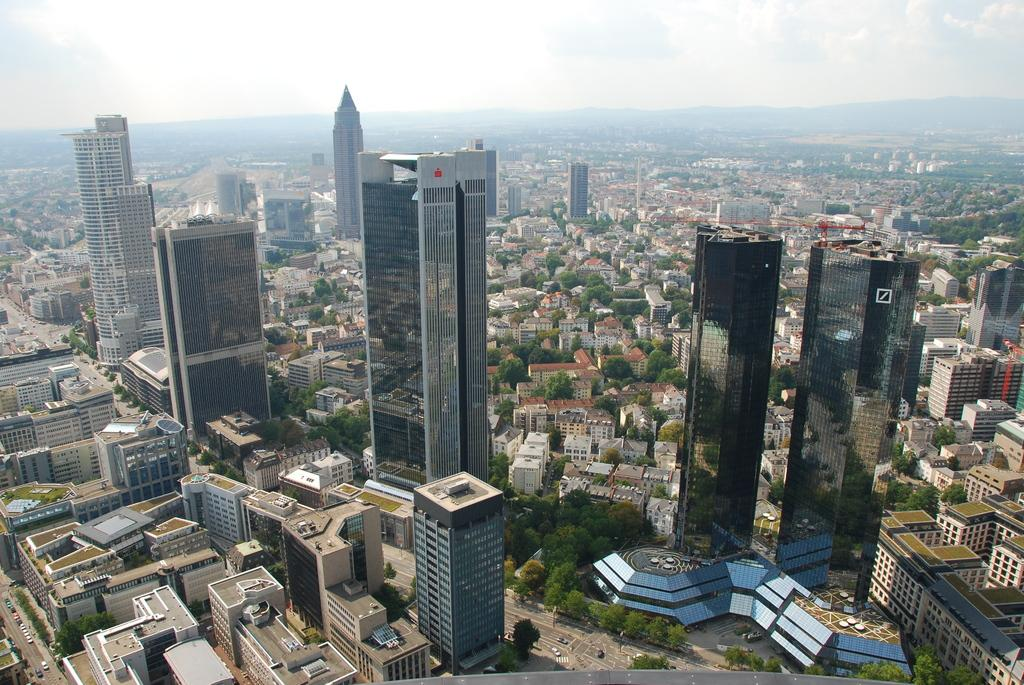What type of structures are present in the image? There is a group of buildings and towers in the image. What other natural elements can be seen in the image? There are trees in the image. What type of transportation is visible in the image? There are vehicles on a pathway in the image. What is visible in the background of the image? Mountains and the sky are visible in the background of the image. How would you describe the weather based on the sky in the image? The sky appears cloudy in the image. What brand of toothpaste is being advertised on the tallest tower in the image? There is no toothpaste or advertisement present on any of the towers in the image. What is the average income of the people living in the buildings shown in the image? There is no information about the income of the people living in the buildings in the image. 